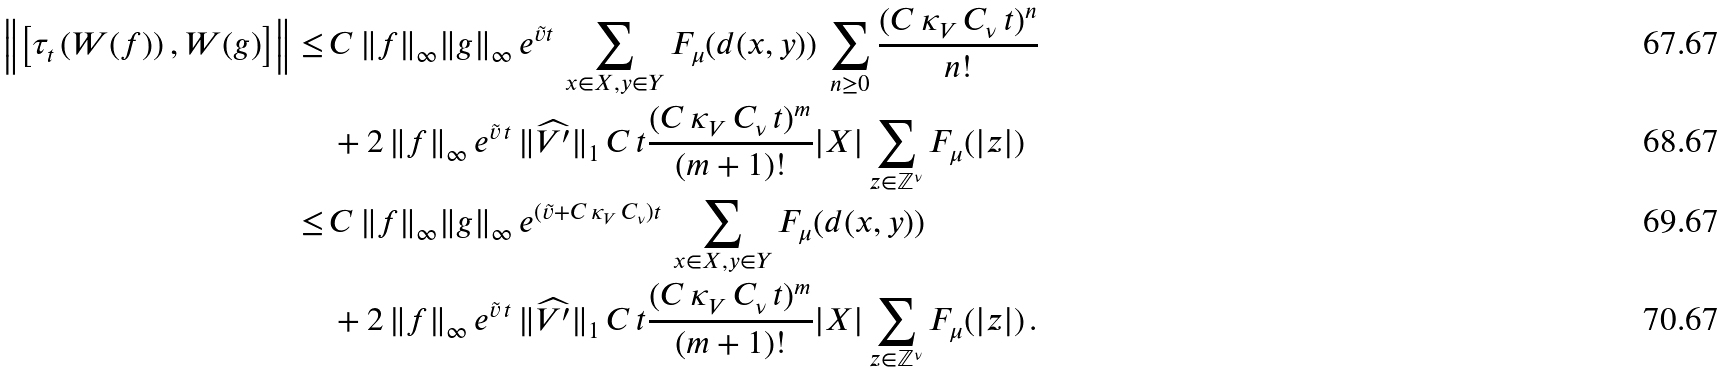Convert formula to latex. <formula><loc_0><loc_0><loc_500><loc_500>\left \| \left [ \tau _ { t } \left ( W ( f ) \right ) , W ( g ) \right ] \right \| \leq \, & C \, \| f \| _ { \infty } \| g \| _ { \infty } \, e ^ { \tilde { v } t } \, \sum _ { x \in X , y \in Y } F _ { \mu } ( d ( x , y ) ) \, \sum _ { n \geq 0 } \frac { ( C \, \kappa _ { V } \, C _ { \nu } \, t ) ^ { n } } { n ! } \\ & + 2 \, \| f \| _ { \infty } \, e ^ { \tilde { v } \, t } \, \| \widehat { V ^ { \prime } } \| _ { 1 } \, C \, t \frac { ( C \, \kappa _ { V } \, C _ { \nu } \, t ) ^ { m } } { ( m + 1 ) ! } | X | \sum _ { z \in \mathbb { Z } ^ { \nu } } F _ { \mu } ( | z | ) \\ \leq \, & C \, \| f \| _ { \infty } \| g \| _ { \infty } \, e ^ { ( \tilde { v } + C \, \kappa _ { V } \, C _ { \nu } ) t } \, \sum _ { x \in X , y \in Y } F _ { \mu } ( d ( x , y ) ) \\ & + 2 \, \| f \| _ { \infty } \, e ^ { \tilde { v } \, t } \, \| \widehat { V ^ { \prime } } \| _ { 1 } \, C \, t \frac { ( C \, \kappa _ { V } \, C _ { \nu } \, t ) ^ { m } } { ( m + 1 ) ! } | X | \sum _ { z \in \mathbb { Z } ^ { \nu } } F _ { \mu } ( | z | ) \, .</formula> 